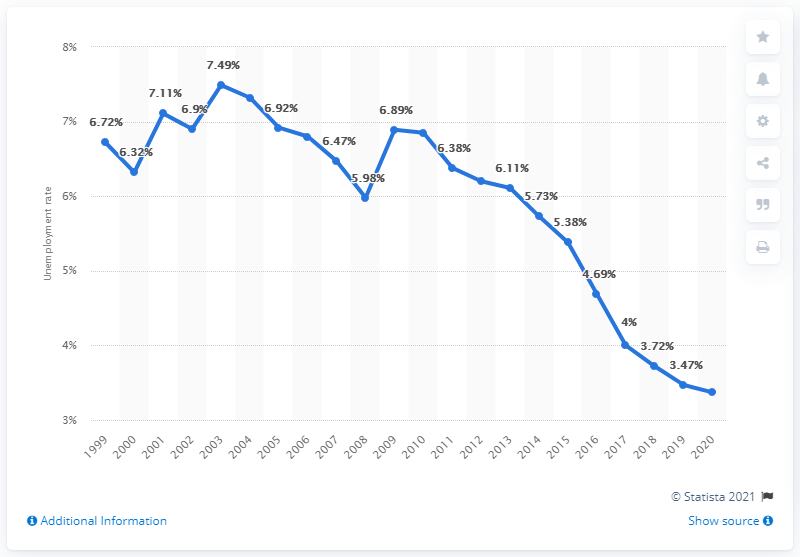Mention a couple of crucial points in this snapshot. The unemployment rate in Malta in 2020 was 3.37%. 